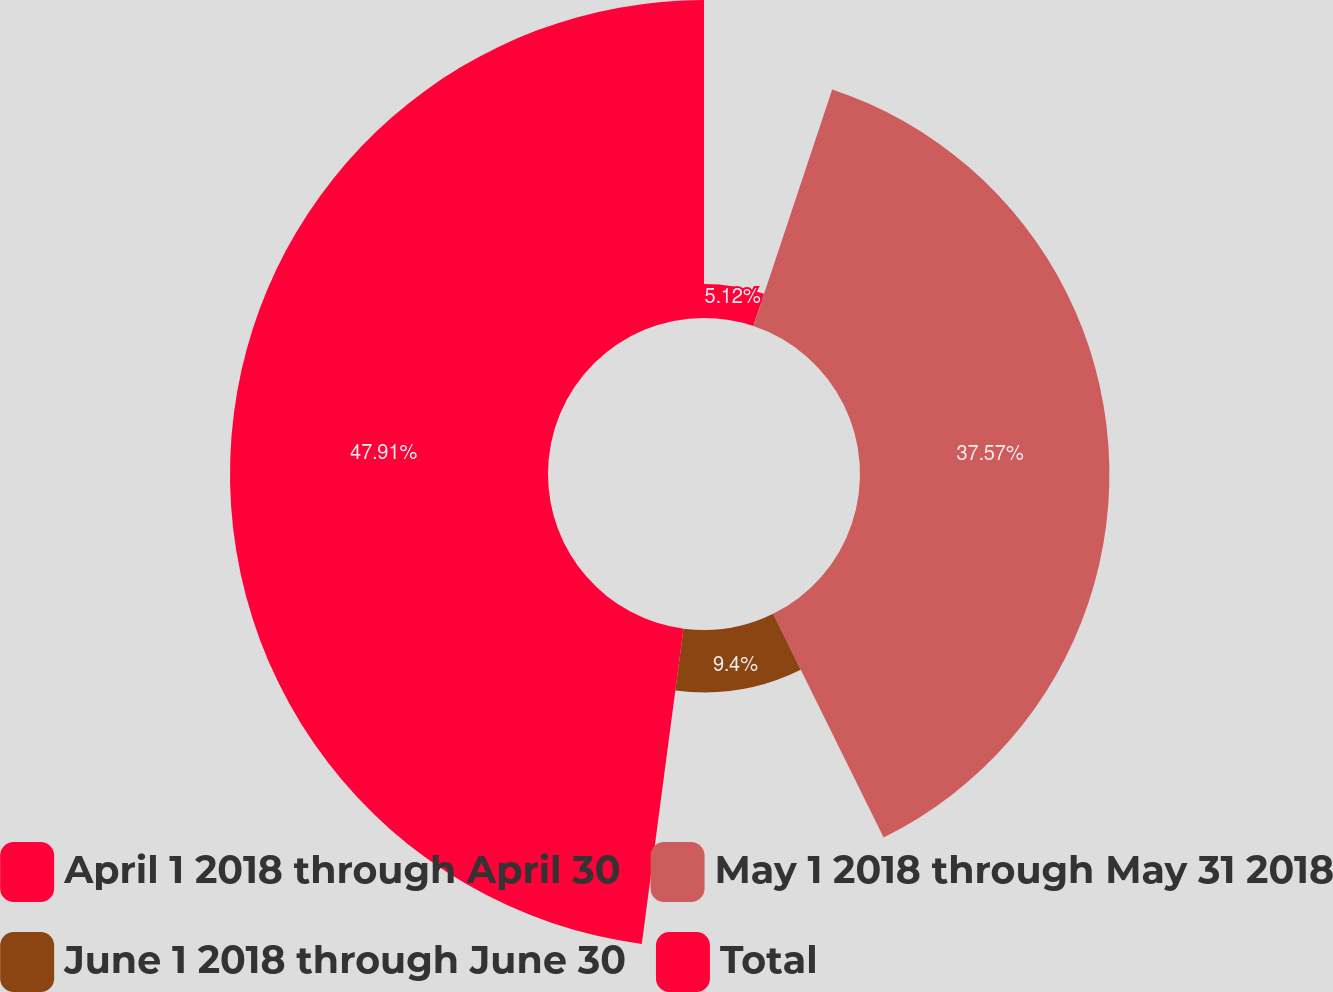Convert chart to OTSL. <chart><loc_0><loc_0><loc_500><loc_500><pie_chart><fcel>April 1 2018 through April 30<fcel>May 1 2018 through May 31 2018<fcel>June 1 2018 through June 30<fcel>Total<nl><fcel>5.12%<fcel>37.57%<fcel>9.4%<fcel>47.9%<nl></chart> 